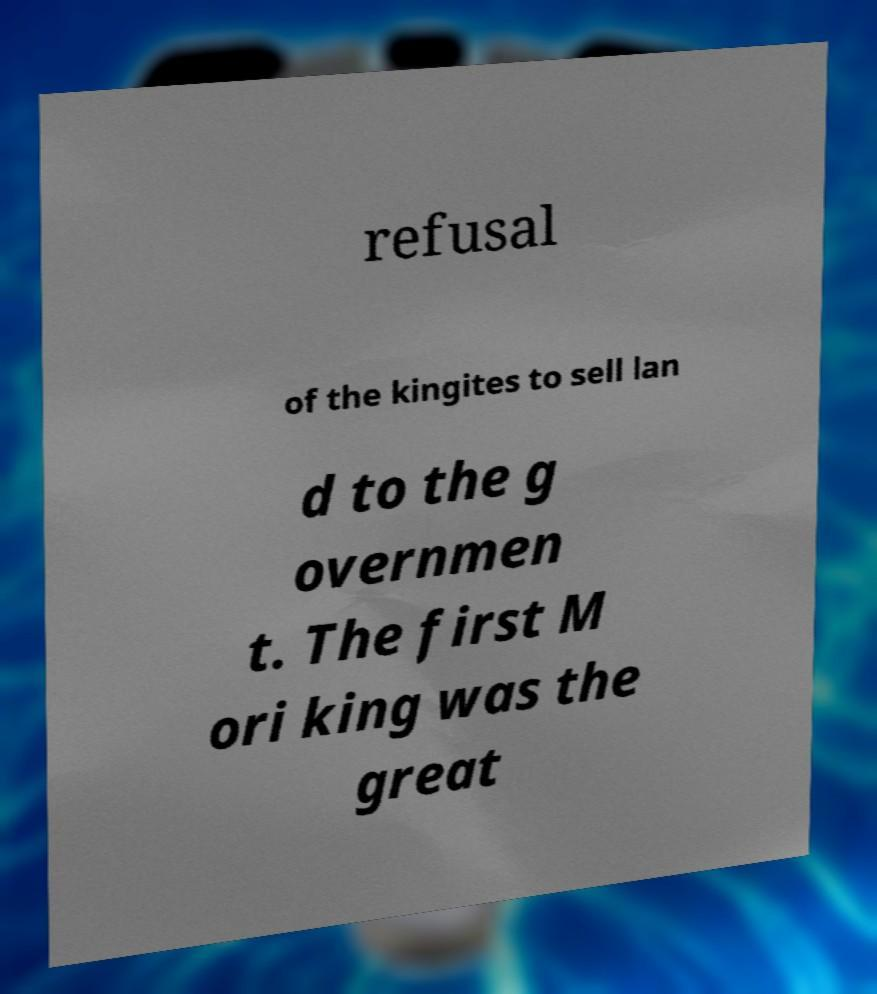Can you accurately transcribe the text from the provided image for me? refusal of the kingites to sell lan d to the g overnmen t. The first M ori king was the great 